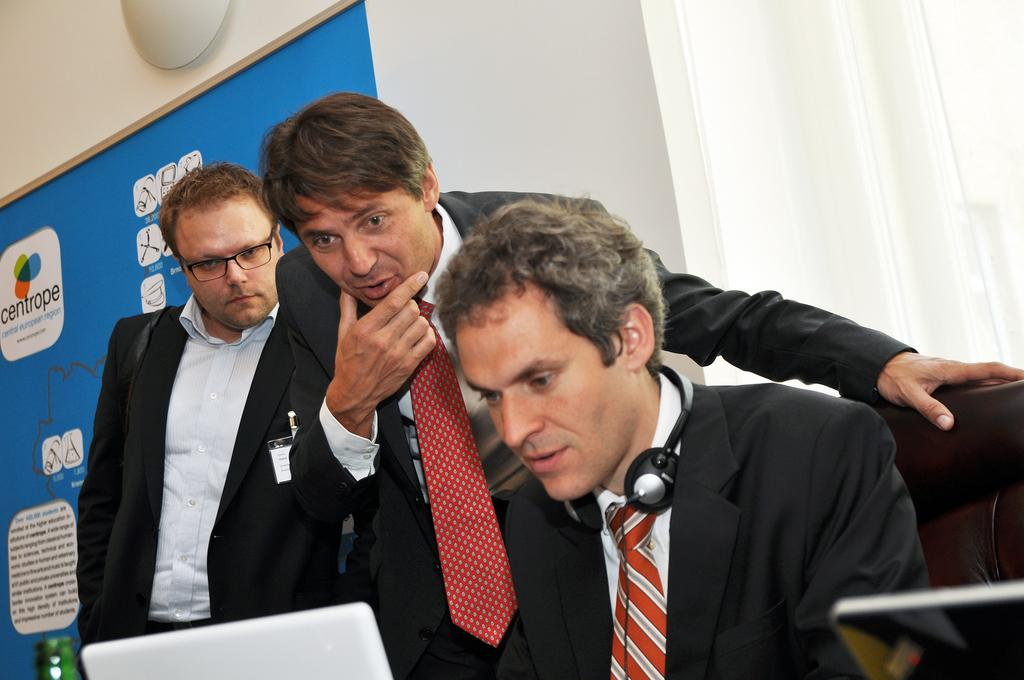How many men are in the image? There are three men in the image. What are the men wearing? The men are wearing black suits. What are the men doing in the image? The men are sitting and working on laptops. What can be seen in the background of the image? There is a blue banner board and a white wall in the background. What type of canvas is being used by the men in the image? There is no canvas present in the image; the men are working on laptops. Is there a prison visible in the image? No, there is no prison present in the image. 